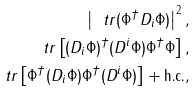Convert formula to latex. <formula><loc_0><loc_0><loc_500><loc_500>\left | \ t r ( \Phi ^ { \dagger } D _ { i } \Phi ) \right | ^ { 2 } , \\ \ t r \left [ ( D _ { i } \Phi ) ^ { \dagger } ( D ^ { i } \Phi ) \Phi ^ { \dagger } \Phi \right ] , \\ \ t r \left [ \Phi ^ { \dagger } ( D _ { i } \Phi ) \Phi ^ { \dagger } ( D ^ { i } \Phi ) \right ] + \text {h.c.} ,</formula> 